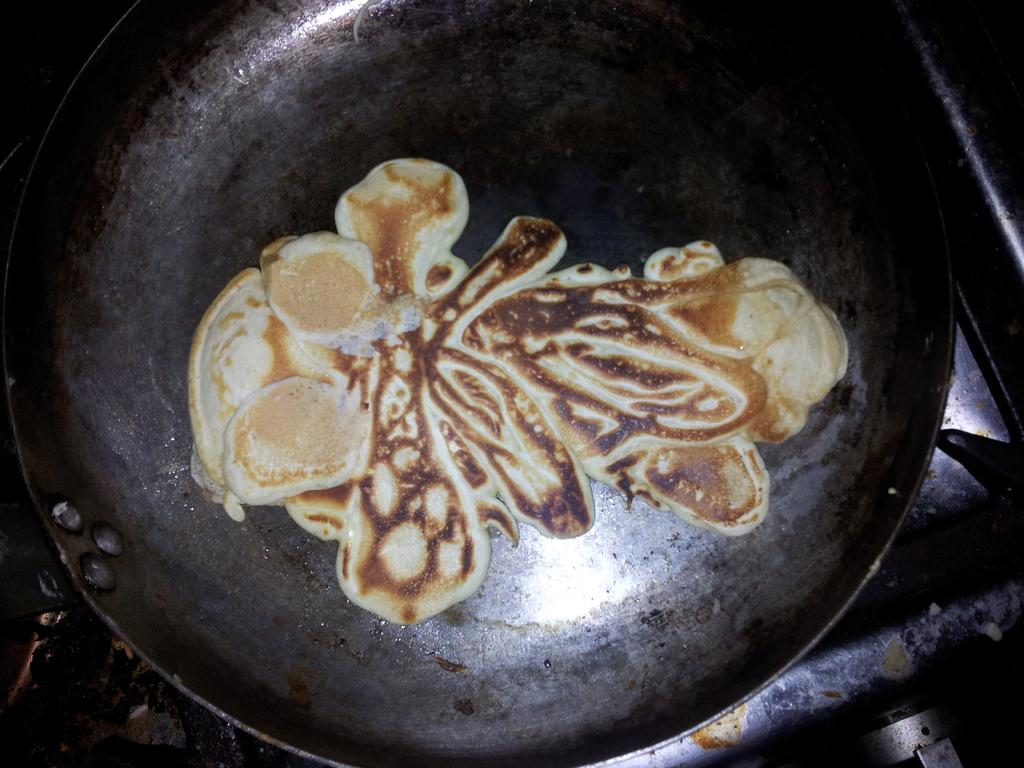What object is present in the image that is used for cooking? There is a black color pan in the image. What is inside the pan? There is food in the pan. Can you describe the appearance of the food? The food has brown and cream colors. How does the light affect the color of the food in the image? There is no mention of light in the image, so we cannot determine how it affects the color of the food. 